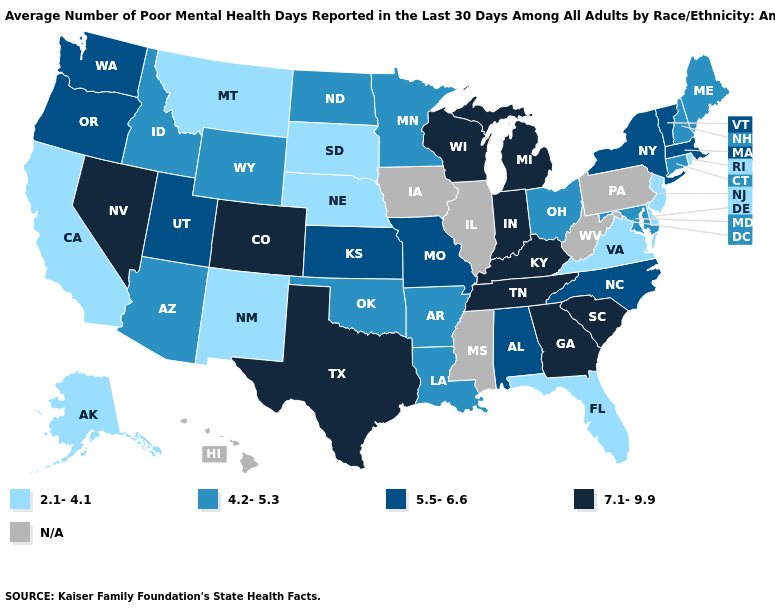Name the states that have a value in the range 5.5-6.6?
Give a very brief answer. Alabama, Kansas, Massachusetts, Missouri, New York, North Carolina, Oregon, Utah, Vermont, Washington. Which states have the lowest value in the USA?
Write a very short answer. Alaska, California, Delaware, Florida, Montana, Nebraska, New Jersey, New Mexico, Rhode Island, South Dakota, Virginia. What is the highest value in the MidWest ?
Short answer required. 7.1-9.9. What is the value of Hawaii?
Keep it brief. N/A. Which states have the lowest value in the USA?
Be succinct. Alaska, California, Delaware, Florida, Montana, Nebraska, New Jersey, New Mexico, Rhode Island, South Dakota, Virginia. Name the states that have a value in the range 2.1-4.1?
Give a very brief answer. Alaska, California, Delaware, Florida, Montana, Nebraska, New Jersey, New Mexico, Rhode Island, South Dakota, Virginia. How many symbols are there in the legend?
Concise answer only. 5. Among the states that border Oregon , does Washington have the highest value?
Give a very brief answer. No. What is the value of Idaho?
Quick response, please. 4.2-5.3. Which states hav the highest value in the South?
Give a very brief answer. Georgia, Kentucky, South Carolina, Tennessee, Texas. Name the states that have a value in the range 4.2-5.3?
Write a very short answer. Arizona, Arkansas, Connecticut, Idaho, Louisiana, Maine, Maryland, Minnesota, New Hampshire, North Dakota, Ohio, Oklahoma, Wyoming. Name the states that have a value in the range N/A?
Answer briefly. Hawaii, Illinois, Iowa, Mississippi, Pennsylvania, West Virginia. Which states hav the highest value in the South?
Keep it brief. Georgia, Kentucky, South Carolina, Tennessee, Texas. Name the states that have a value in the range 4.2-5.3?
Concise answer only. Arizona, Arkansas, Connecticut, Idaho, Louisiana, Maine, Maryland, Minnesota, New Hampshire, North Dakota, Ohio, Oklahoma, Wyoming. 